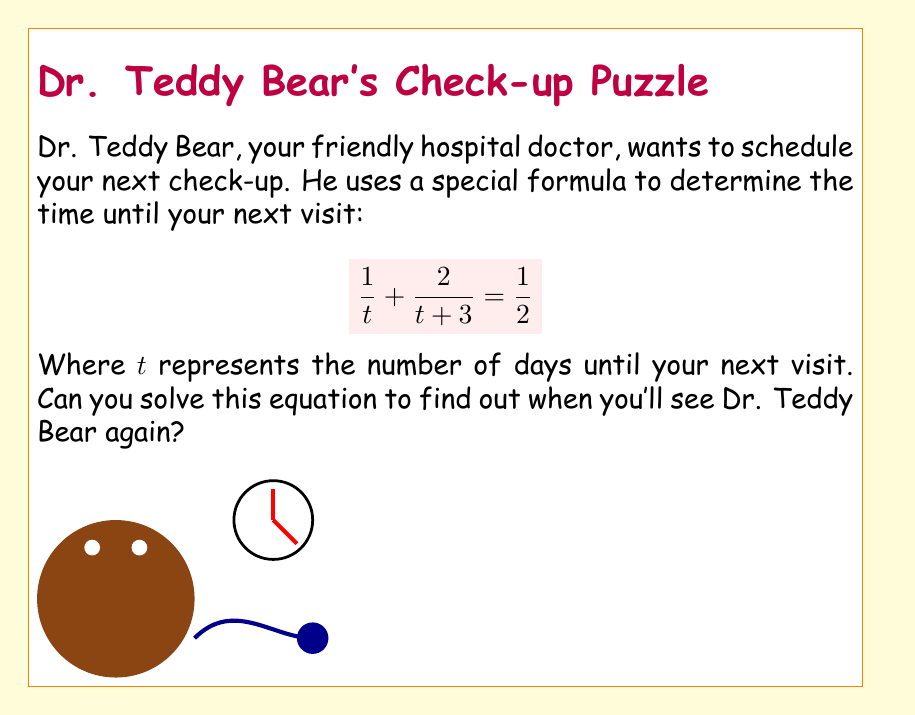Can you answer this question? Let's solve this equation step by step:

1) First, we start with the equation:
   $$\frac{1}{t} + \frac{2}{t+3} = \frac{1}{2}$$

2) To solve this, we need to find a common denominator. The least common multiple of $t$, $(t+3)$, and 2 is $2t(t+3)$. Let's multiply both sides by this:
   $$2t(t+3) \cdot (\frac{1}{t} + \frac{2}{t+3} = \frac{1}{2})$$

3) This gives us:
   $$2(t+3) + 2t = t(t+3)$$

4) Expand the brackets:
   $$2t + 6 + 2t = t^2 + 3t$$

5) Combine like terms:
   $$4t + 6 = t^2 + 3t$$

6) Rearrange to standard form:
   $$t^2 - t - 6 = 0$$

7) This is a quadratic equation. We can solve it using the quadratic formula: $t = \frac{-b \pm \sqrt{b^2 - 4ac}}{2a}$
   Where $a=1$, $b=-1$, and $c=-6$

8) Plugging in these values:
   $$t = \frac{1 \pm \sqrt{1 - 4(1)(-6)}}{2(1)} = \frac{1 \pm \sqrt{25}}{2} = \frac{1 \pm 5}{2}$$

9) This gives us two solutions:
   $$t = \frac{1 + 5}{2} = 3$$ or $$t = \frac{1 - 5}{2} = -2$$

10) Since time can't be negative, we discard the negative solution.

Therefore, your next visit with Dr. Teddy Bear will be in 3 days.
Answer: 3 days 